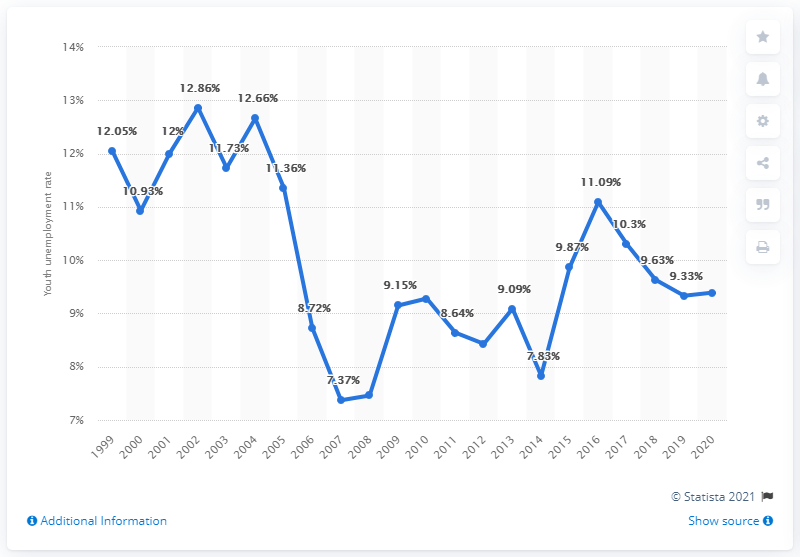What impact did the 2008 global financial crisis have on youth unemployment in Norway? The global financial crisis of 2008 appears to have caused an increase in youth unemployment in Norway, as observed by the rise from 7.37% in 2008 to 11.73% in 2010. This trend was common across many countries where the crisis led to job cuts, slower economic activity, and reduced hiring, which often disproportionately affects younger workers. 